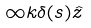<formula> <loc_0><loc_0><loc_500><loc_500>\infty k \delta ( s ) \hat { z }</formula> 